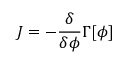<formula> <loc_0><loc_0><loc_500><loc_500>J = - { \frac { \delta } { \delta \phi } } \Gamma [ \phi ]</formula> 